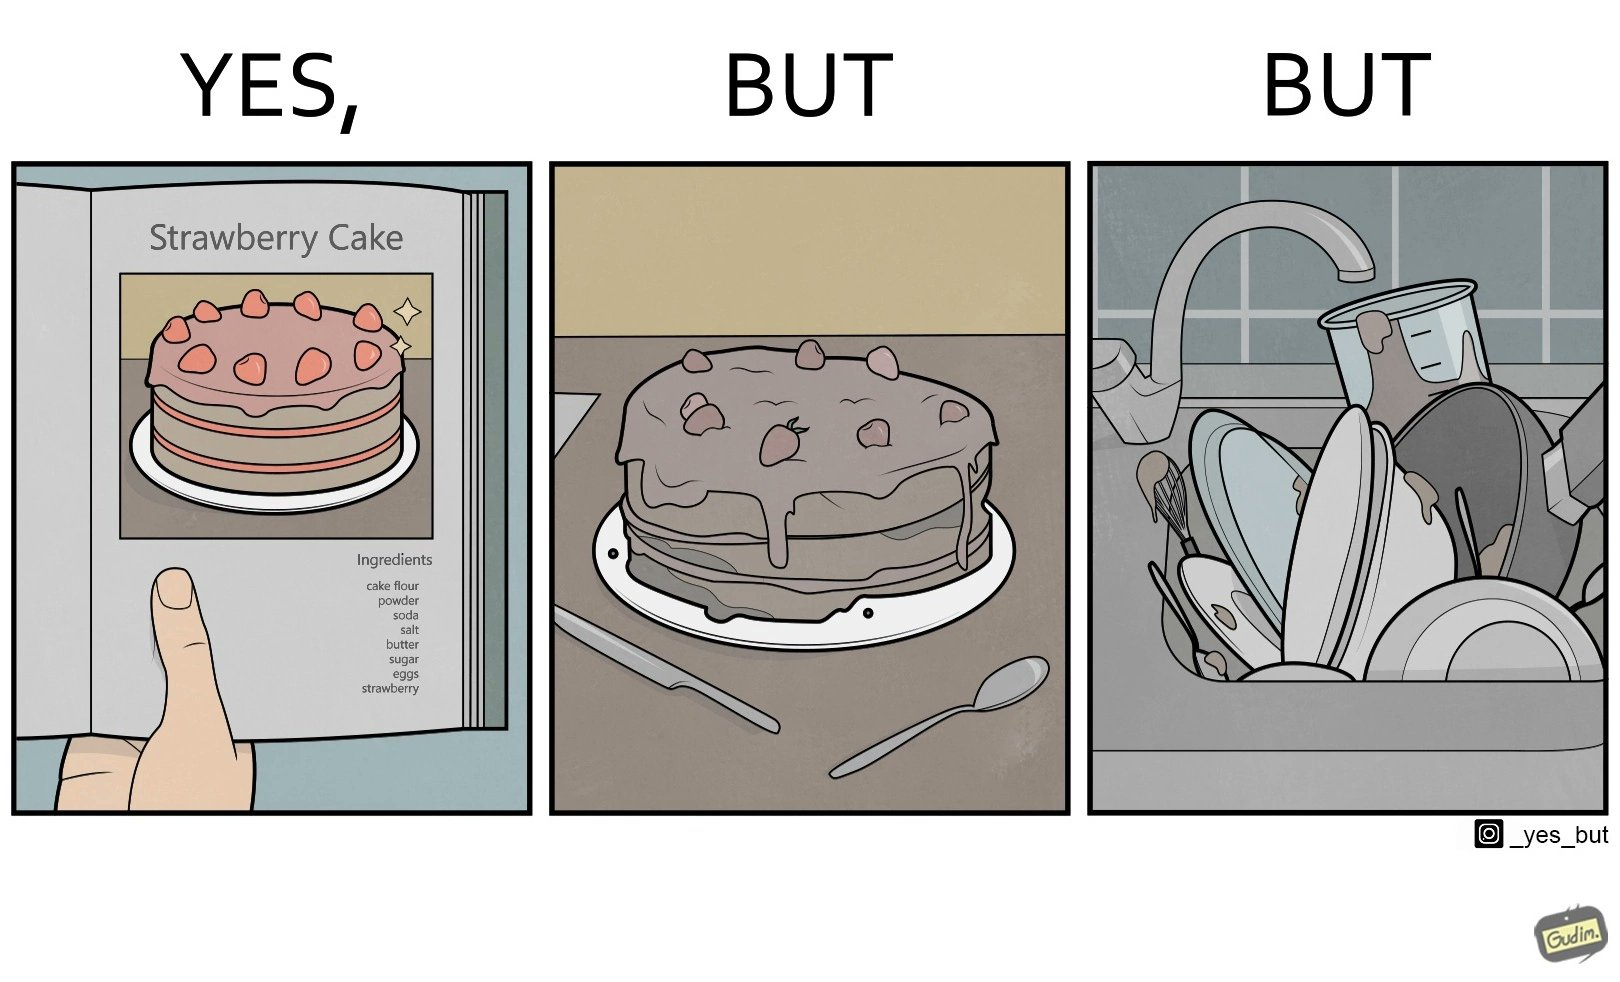What is shown in this image? The image is funny, as when making a strawberry cake using  a recipe book, the outcome is not quite what is expected, and one has to wash the used utensils afterwards as well. 